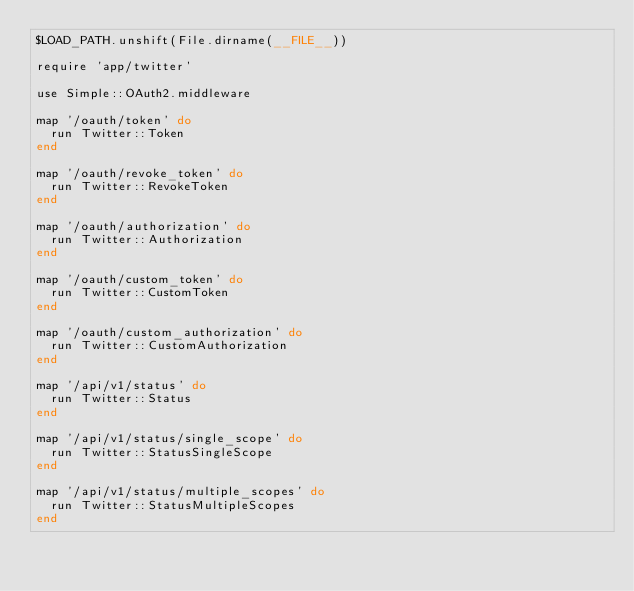Convert code to text. <code><loc_0><loc_0><loc_500><loc_500><_Ruby_>$LOAD_PATH.unshift(File.dirname(__FILE__))

require 'app/twitter'

use Simple::OAuth2.middleware

map '/oauth/token' do
  run Twitter::Token
end

map '/oauth/revoke_token' do
  run Twitter::RevokeToken
end

map '/oauth/authorization' do
  run Twitter::Authorization
end

map '/oauth/custom_token' do
  run Twitter::CustomToken
end

map '/oauth/custom_authorization' do
  run Twitter::CustomAuthorization
end

map '/api/v1/status' do
  run Twitter::Status
end

map '/api/v1/status/single_scope' do
  run Twitter::StatusSingleScope
end

map '/api/v1/status/multiple_scopes' do
  run Twitter::StatusMultipleScopes
end
</code> 